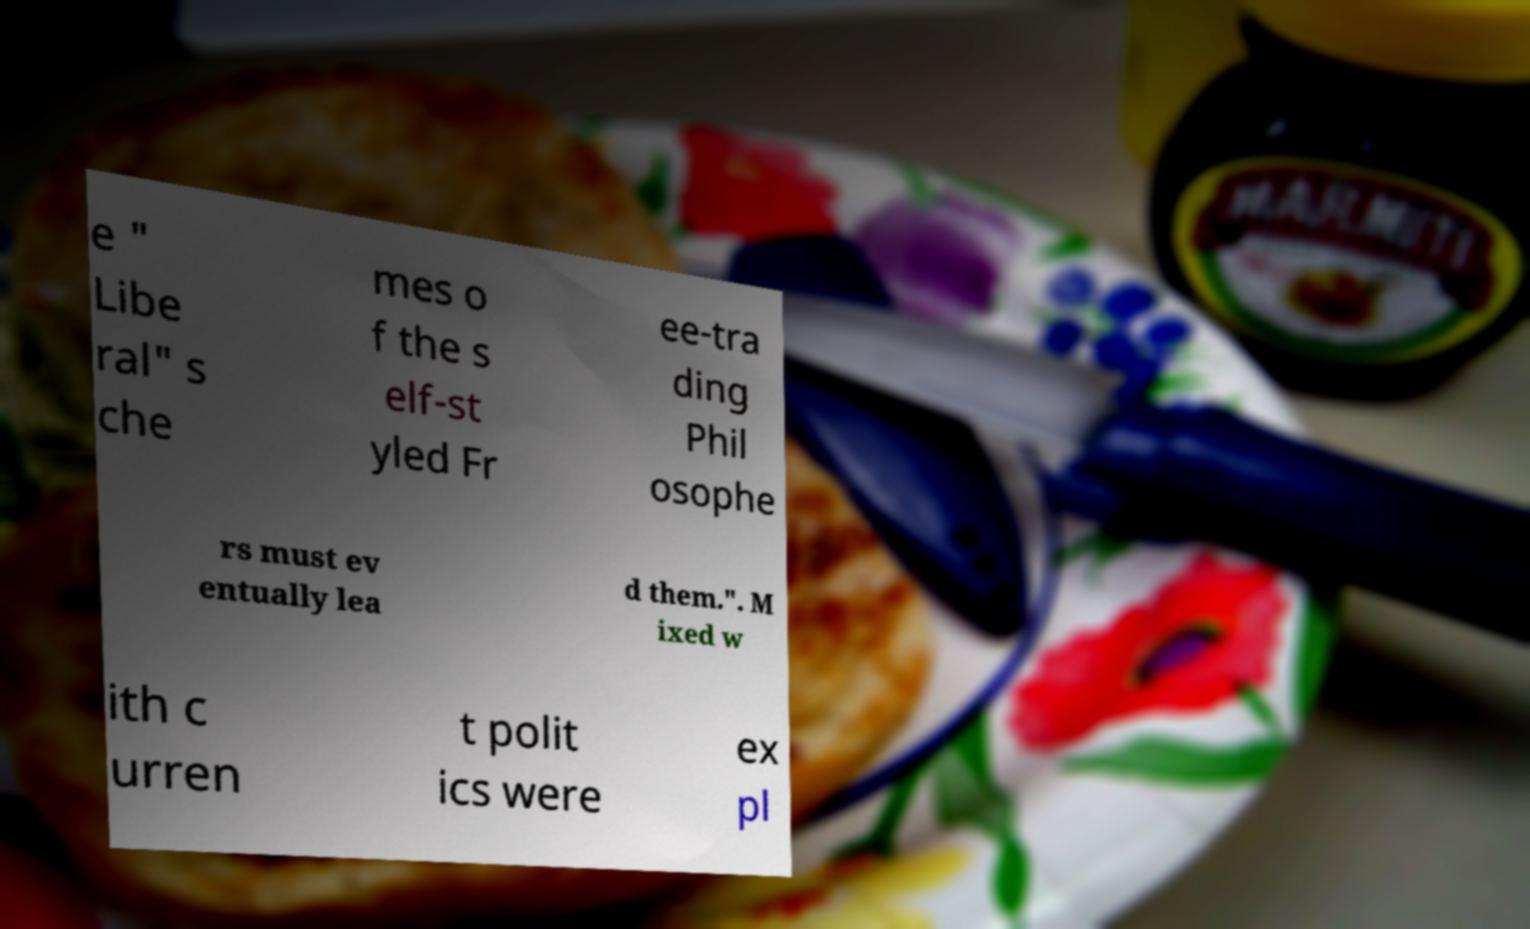I need the written content from this picture converted into text. Can you do that? e " Libe ral" s che mes o f the s elf-st yled Fr ee-tra ding Phil osophe rs must ev entually lea d them.". M ixed w ith c urren t polit ics were ex pl 